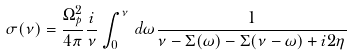Convert formula to latex. <formula><loc_0><loc_0><loc_500><loc_500>\sigma ( \nu ) = \frac { \Omega _ { p } ^ { 2 } } { 4 \pi } \frac { i } { \nu } \int _ { 0 } ^ { \nu } \, d \omega \frac { 1 } { \nu - \Sigma ( \omega ) - \Sigma ( \nu - \omega ) + i 2 \eta }</formula> 